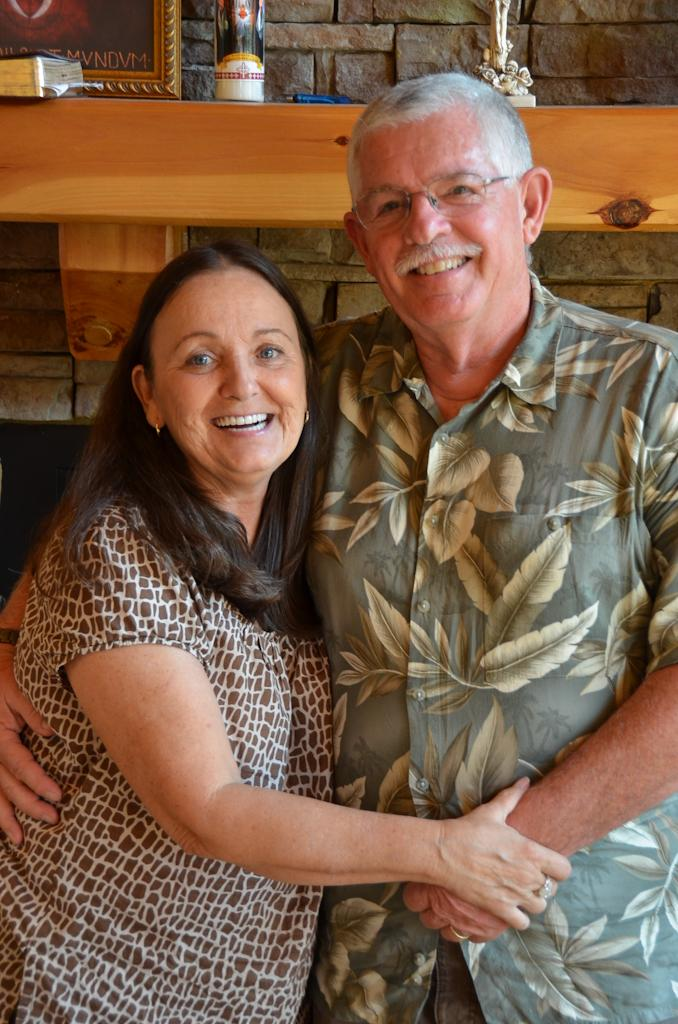Who is present in the image? There is a man and a woman in the image. What expressions do the man and woman have? Both the man and woman are smiling in the image. What can be seen around the man and woman? There is a frame visible in the image. What else can be seen in the background of the image? There are other items on a shelf in the background. Can you see any fish swimming in the image? There are no fish visible in the image. What is the thumbprint on the man's forehead in the image? There is no thumbprint or any reference to a thumb on the man's forehead in the image. 